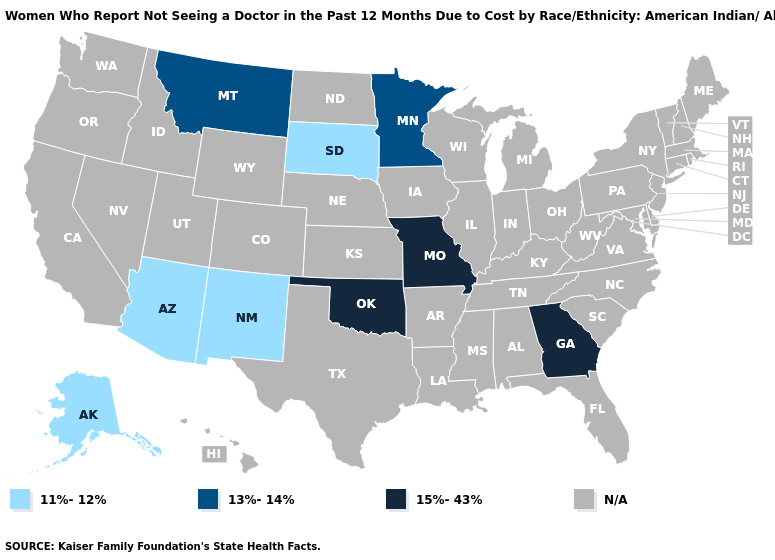Which states hav the highest value in the West?
Concise answer only. Montana. How many symbols are there in the legend?
Quick response, please. 4. Does the first symbol in the legend represent the smallest category?
Give a very brief answer. Yes. What is the value of Nevada?
Write a very short answer. N/A. Name the states that have a value in the range 15%-43%?
Be succinct. Georgia, Missouri, Oklahoma. Which states have the highest value in the USA?
Short answer required. Georgia, Missouri, Oklahoma. Name the states that have a value in the range 15%-43%?
Give a very brief answer. Georgia, Missouri, Oklahoma. Is the legend a continuous bar?
Write a very short answer. No. Does Oklahoma have the lowest value in the USA?
Short answer required. No. What is the value of California?
Write a very short answer. N/A. What is the value of Maryland?
Answer briefly. N/A. Among the states that border North Carolina , which have the highest value?
Quick response, please. Georgia. What is the value of Missouri?
Short answer required. 15%-43%. 